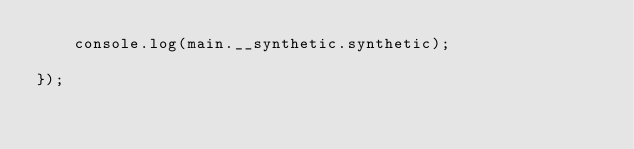<code> <loc_0><loc_0><loc_500><loc_500><_JavaScript_>	console.log(main.__synthetic.synthetic);

});
</code> 